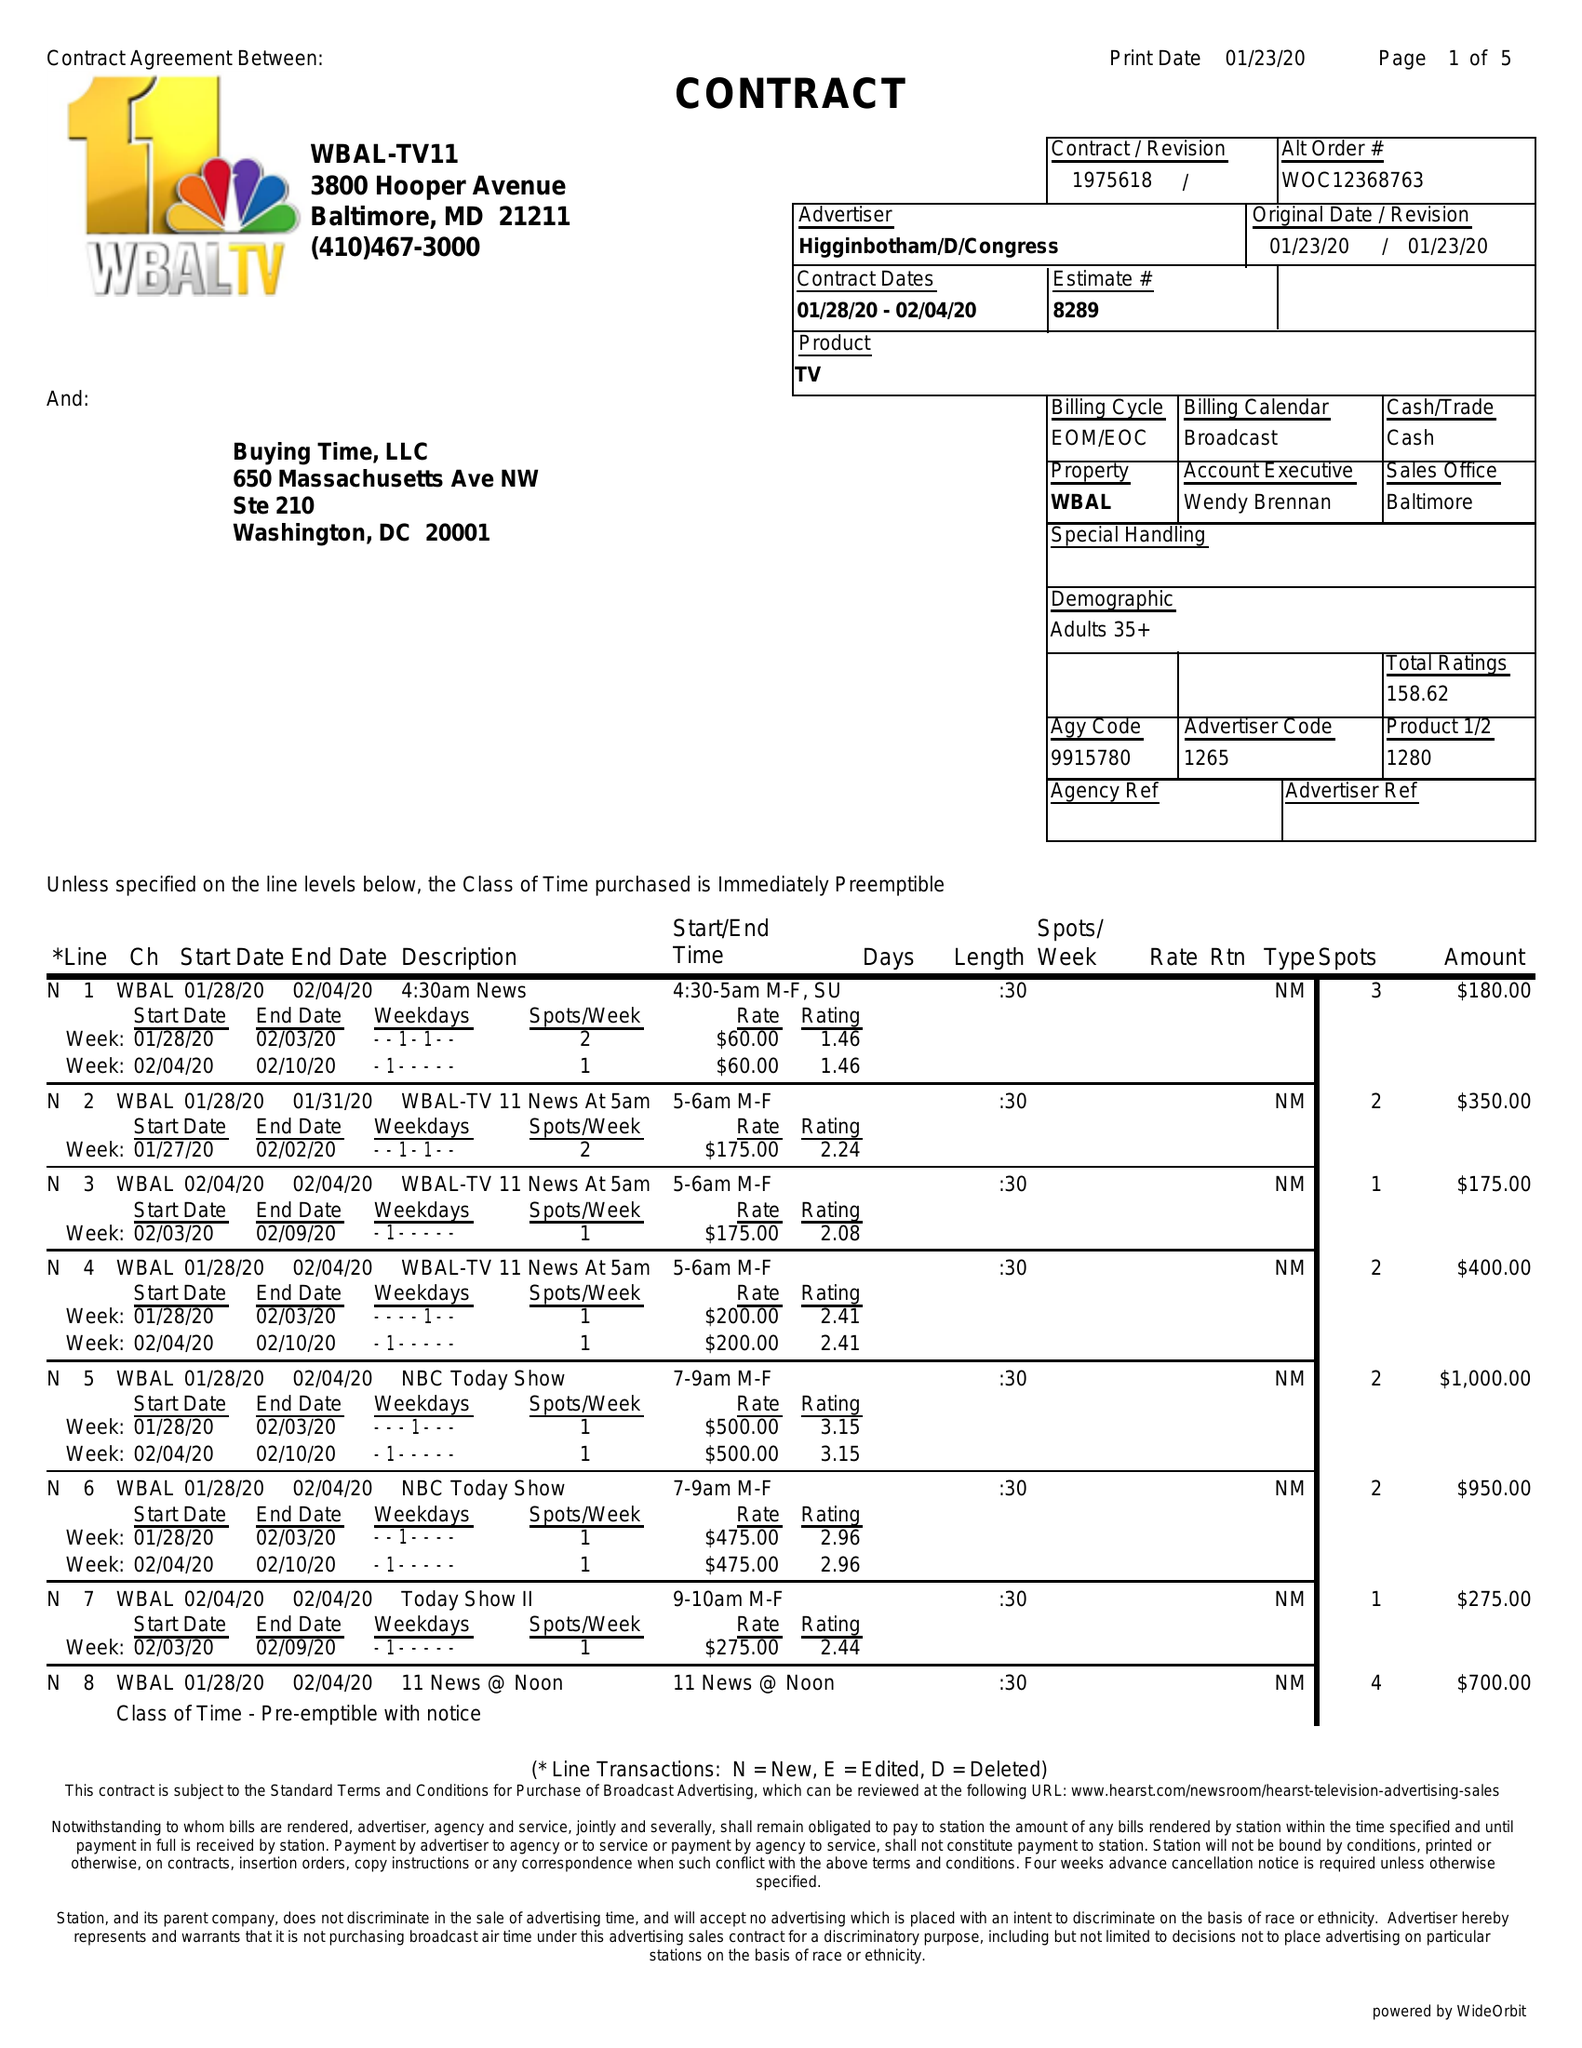What is the value for the flight_to?
Answer the question using a single word or phrase. 02/04/20 